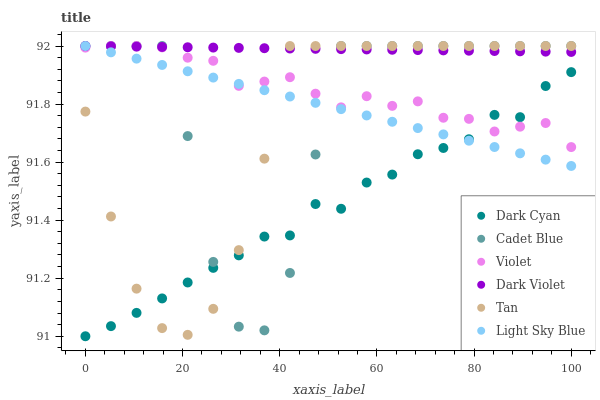Does Dark Cyan have the minimum area under the curve?
Answer yes or no. Yes. Does Dark Violet have the maximum area under the curve?
Answer yes or no. Yes. Does Light Sky Blue have the minimum area under the curve?
Answer yes or no. No. Does Light Sky Blue have the maximum area under the curve?
Answer yes or no. No. Is Light Sky Blue the smoothest?
Answer yes or no. Yes. Is Cadet Blue the roughest?
Answer yes or no. Yes. Is Dark Violet the smoothest?
Answer yes or no. No. Is Dark Violet the roughest?
Answer yes or no. No. Does Dark Cyan have the lowest value?
Answer yes or no. Yes. Does Light Sky Blue have the lowest value?
Answer yes or no. No. Does Tan have the highest value?
Answer yes or no. Yes. Does Dark Cyan have the highest value?
Answer yes or no. No. Is Dark Cyan less than Dark Violet?
Answer yes or no. Yes. Is Dark Violet greater than Dark Cyan?
Answer yes or no. Yes. Does Violet intersect Cadet Blue?
Answer yes or no. Yes. Is Violet less than Cadet Blue?
Answer yes or no. No. Is Violet greater than Cadet Blue?
Answer yes or no. No. Does Dark Cyan intersect Dark Violet?
Answer yes or no. No. 